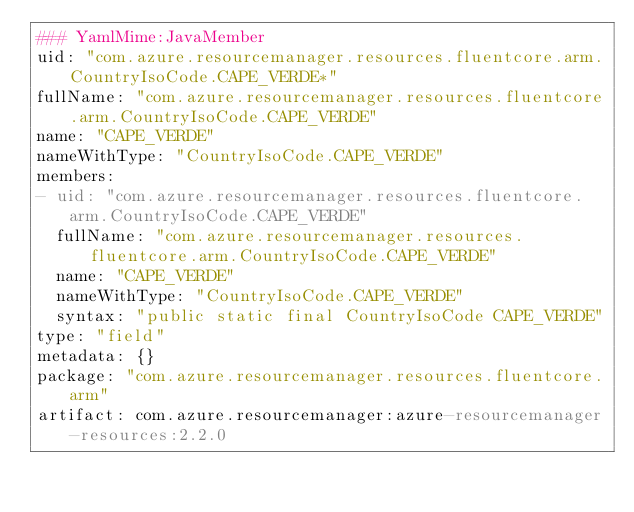Convert code to text. <code><loc_0><loc_0><loc_500><loc_500><_YAML_>### YamlMime:JavaMember
uid: "com.azure.resourcemanager.resources.fluentcore.arm.CountryIsoCode.CAPE_VERDE*"
fullName: "com.azure.resourcemanager.resources.fluentcore.arm.CountryIsoCode.CAPE_VERDE"
name: "CAPE_VERDE"
nameWithType: "CountryIsoCode.CAPE_VERDE"
members:
- uid: "com.azure.resourcemanager.resources.fluentcore.arm.CountryIsoCode.CAPE_VERDE"
  fullName: "com.azure.resourcemanager.resources.fluentcore.arm.CountryIsoCode.CAPE_VERDE"
  name: "CAPE_VERDE"
  nameWithType: "CountryIsoCode.CAPE_VERDE"
  syntax: "public static final CountryIsoCode CAPE_VERDE"
type: "field"
metadata: {}
package: "com.azure.resourcemanager.resources.fluentcore.arm"
artifact: com.azure.resourcemanager:azure-resourcemanager-resources:2.2.0
</code> 